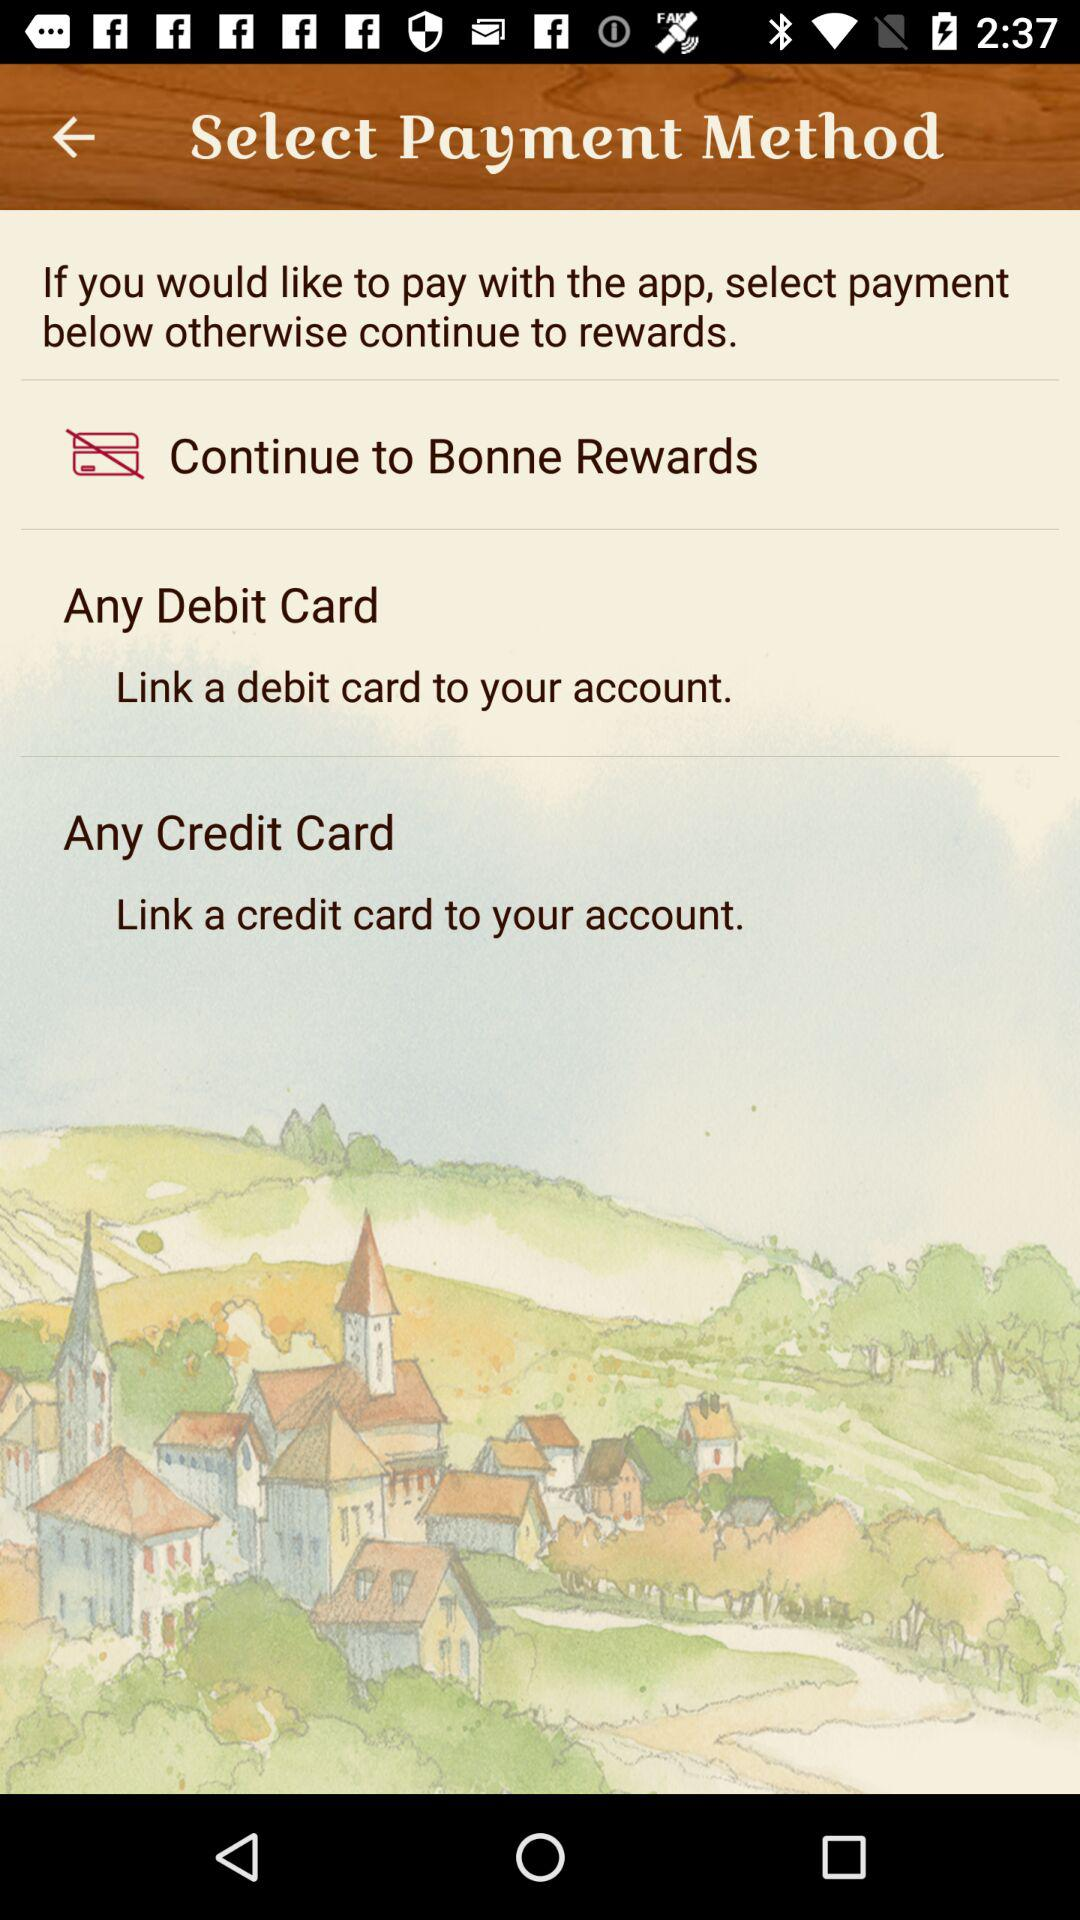What is the name of the user?
When the provided information is insufficient, respond with <no answer>. <no answer> 